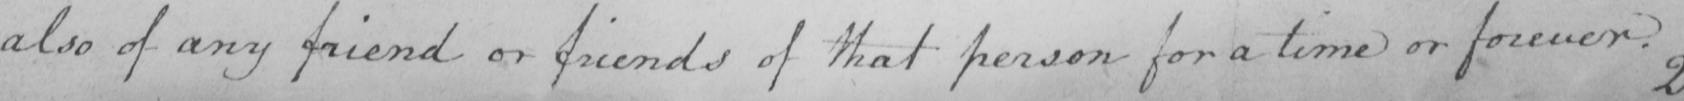Please transcribe the handwritten text in this image. also of any friend or friends of that person for a time or forever . 